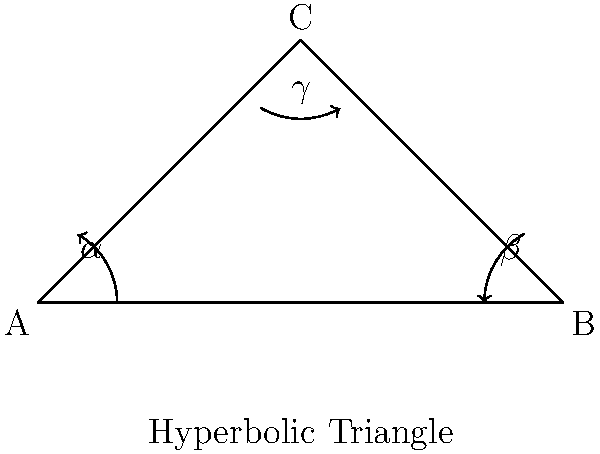While helping your child with geometry homework, you encounter a problem about triangles in non-Euclidean geometry. In a hyperbolic plane, the sum of the interior angles of a triangle ($\alpha + \beta + \gamma$) is always less than 180°. If the difference between 180° and the sum of the angles in a hyperbolic triangle is called the defect ($\delta$), which can be calculated as $\delta = 180° - (\alpha + \beta + \gamma)$, what is the maximum possible value for the defect of a hyperbolic triangle? To understand the maximum defect of a hyperbolic triangle, let's follow these steps:

1. In Euclidean geometry, the sum of angles in a triangle is always 180°. However, in hyperbolic geometry, this sum is always less than 180°.

2. The defect ($\delta$) is defined as:
   $\delta = 180° - (\alpha + \beta + \gamma)$

3. In hyperbolic geometry, as the triangle gets larger, its angles approach 0°.

4. The theoretical limit for the sum of angles in a hyperbolic triangle is 0°.

5. Therefore, the maximum defect occurs when the sum of angles is closest to 0°:
   $\delta_{max} = 180° - (0° + 0° + 0°) = 180°$

6. This means that the maximum possible defect for a hyperbolic triangle is 180°.

This concept, while abstract, helps illustrate how geometry in a hyperbolic plane differs from the familiar Euclidean geometry, which might be useful when explaining different types of mathematical thinking to your child.
Answer: 180° 